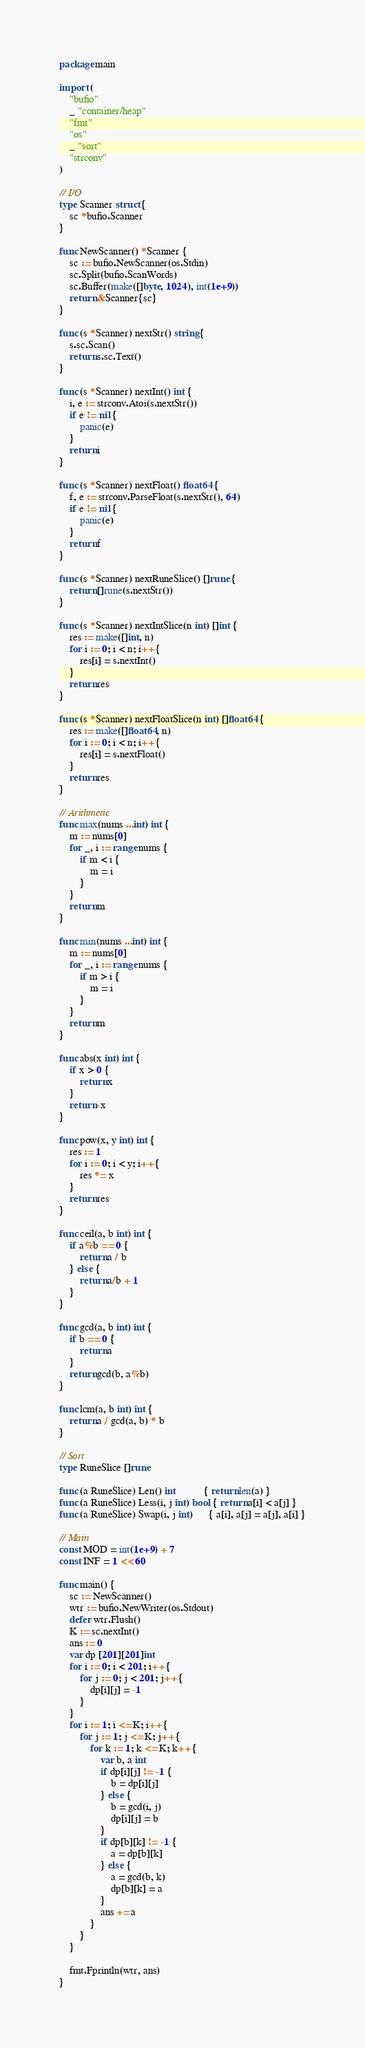Convert code to text. <code><loc_0><loc_0><loc_500><loc_500><_Go_>package main

import (
	"bufio"
	_ "container/heap"
	"fmt"
	"os"
	_ "sort"
	"strconv"
)

// I/O
type Scanner struct {
	sc *bufio.Scanner
}

func NewScanner() *Scanner {
	sc := bufio.NewScanner(os.Stdin)
	sc.Split(bufio.ScanWords)
	sc.Buffer(make([]byte, 1024), int(1e+9))
	return &Scanner{sc}
}

func (s *Scanner) nextStr() string {
	s.sc.Scan()
	return s.sc.Text()
}

func (s *Scanner) nextInt() int {
	i, e := strconv.Atoi(s.nextStr())
	if e != nil {
		panic(e)
	}
	return i
}

func (s *Scanner) nextFloat() float64 {
	f, e := strconv.ParseFloat(s.nextStr(), 64)
	if e != nil {
		panic(e)
	}
	return f
}

func (s *Scanner) nextRuneSlice() []rune {
	return []rune(s.nextStr())
}

func (s *Scanner) nextIntSlice(n int) []int {
	res := make([]int, n)
	for i := 0; i < n; i++ {
		res[i] = s.nextInt()
	}
	return res
}

func (s *Scanner) nextFloatSlice(n int) []float64 {
	res := make([]float64, n)
	for i := 0; i < n; i++ {
		res[i] = s.nextFloat()
	}
	return res
}

// Arithmetic
func max(nums ...int) int {
	m := nums[0]
	for _, i := range nums {
		if m < i {
			m = i
		}
	}
	return m
}

func min(nums ...int) int {
	m := nums[0]
	for _, i := range nums {
		if m > i {
			m = i
		}
	}
	return m
}

func abs(x int) int {
	if x > 0 {
		return x
	}
	return -x
}

func pow(x, y int) int {
	res := 1
	for i := 0; i < y; i++ {
		res *= x
	}
	return res
}

func ceil(a, b int) int {
	if a%b == 0 {
		return a / b
	} else {
		return a/b + 1
	}
}

func gcd(a, b int) int {
	if b == 0 {
		return a
	}
	return gcd(b, a%b)
}

func lcm(a, b int) int {
	return a / gcd(a, b) * b
}

// Sort
type RuneSlice []rune

func (a RuneSlice) Len() int           { return len(a) }
func (a RuneSlice) Less(i, j int) bool { return a[i] < a[j] }
func (a RuneSlice) Swap(i, j int)      { a[i], a[j] = a[j], a[i] }

// Main
const MOD = int(1e+9) + 7
const INF = 1 << 60

func main() {
	sc := NewScanner()
	wtr := bufio.NewWriter(os.Stdout)
	defer wtr.Flush()
	K := sc.nextInt()
	ans := 0
	var dp [201][201]int
	for i := 0; i < 201; i++ {
		for j := 0; j < 201; j++ {
			dp[i][j] = -1
		}
	}
	for i := 1; i <= K; i++ {
		for j := 1; j <= K; j++ {
			for k := 1; k <= K; k++ {
				var b, a int
				if dp[i][j] != -1 {
					b = dp[i][j]
				} else {
					b = gcd(i, j)
					dp[i][j] = b
				}
				if dp[b][k] != -1 {
					a = dp[b][k]
				} else {
					a = gcd(b, k)
					dp[b][k] = a
				}
				ans += a
			}
		}
	}

	fmt.Fprintln(wtr, ans)
}
</code> 